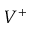Convert formula to latex. <formula><loc_0><loc_0><loc_500><loc_500>V ^ { + }</formula> 